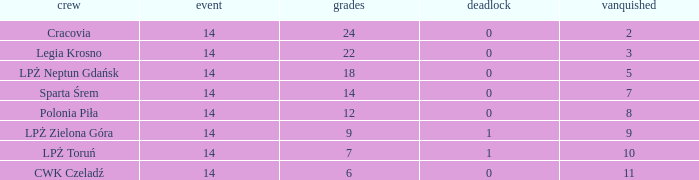What is the lowest points for a match before 14? None. 